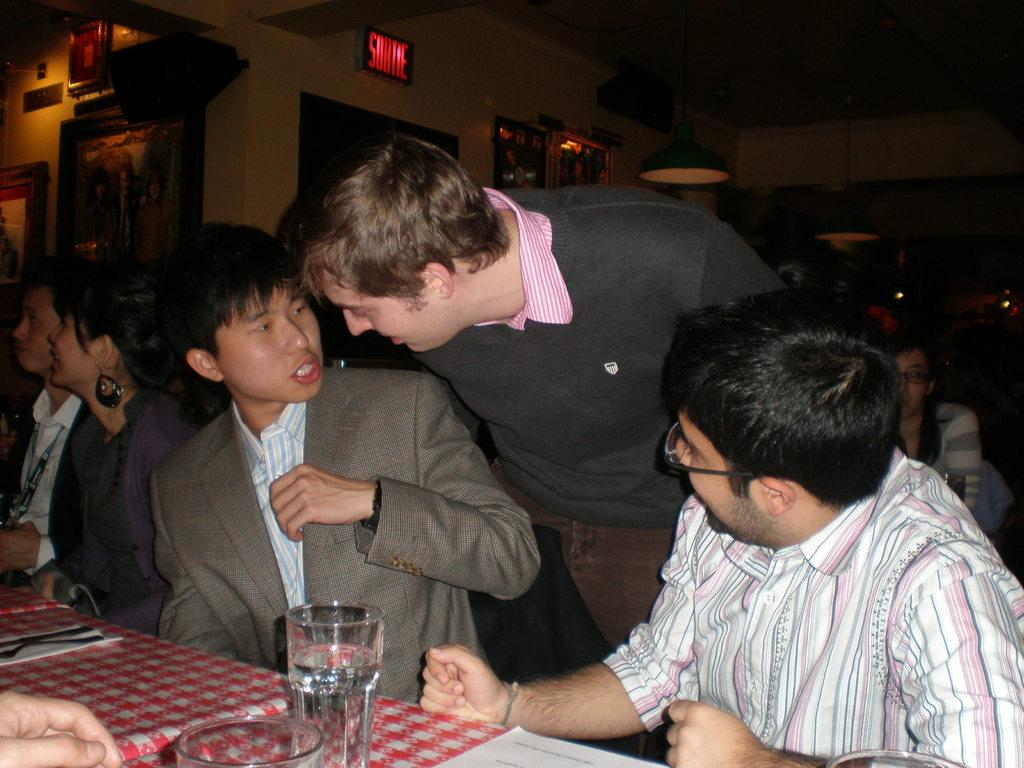How many people are in the image? There is a group of people in the image. What are the people doing in the image? The people are sitting on chairs. What is on the table in the image? There is a glass, a tissue, and a spoon on the table. What can be seen in the background of the image? In the background of the image, there are windows, a photo frame, and lights. What type of prose is being read by the people in the image? There is no indication in the image that the people are reading any prose. 